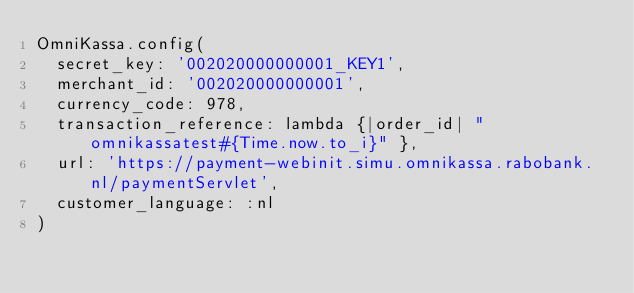Convert code to text. <code><loc_0><loc_0><loc_500><loc_500><_Ruby_>OmniKassa.config(
  secret_key: '002020000000001_KEY1',
  merchant_id: '002020000000001',
  currency_code: 978,
  transaction_reference: lambda {|order_id| "omnikassatest#{Time.now.to_i}" },
  url: 'https://payment-webinit.simu.omnikassa.rabobank.nl/paymentServlet',
  customer_language: :nl
)

</code> 